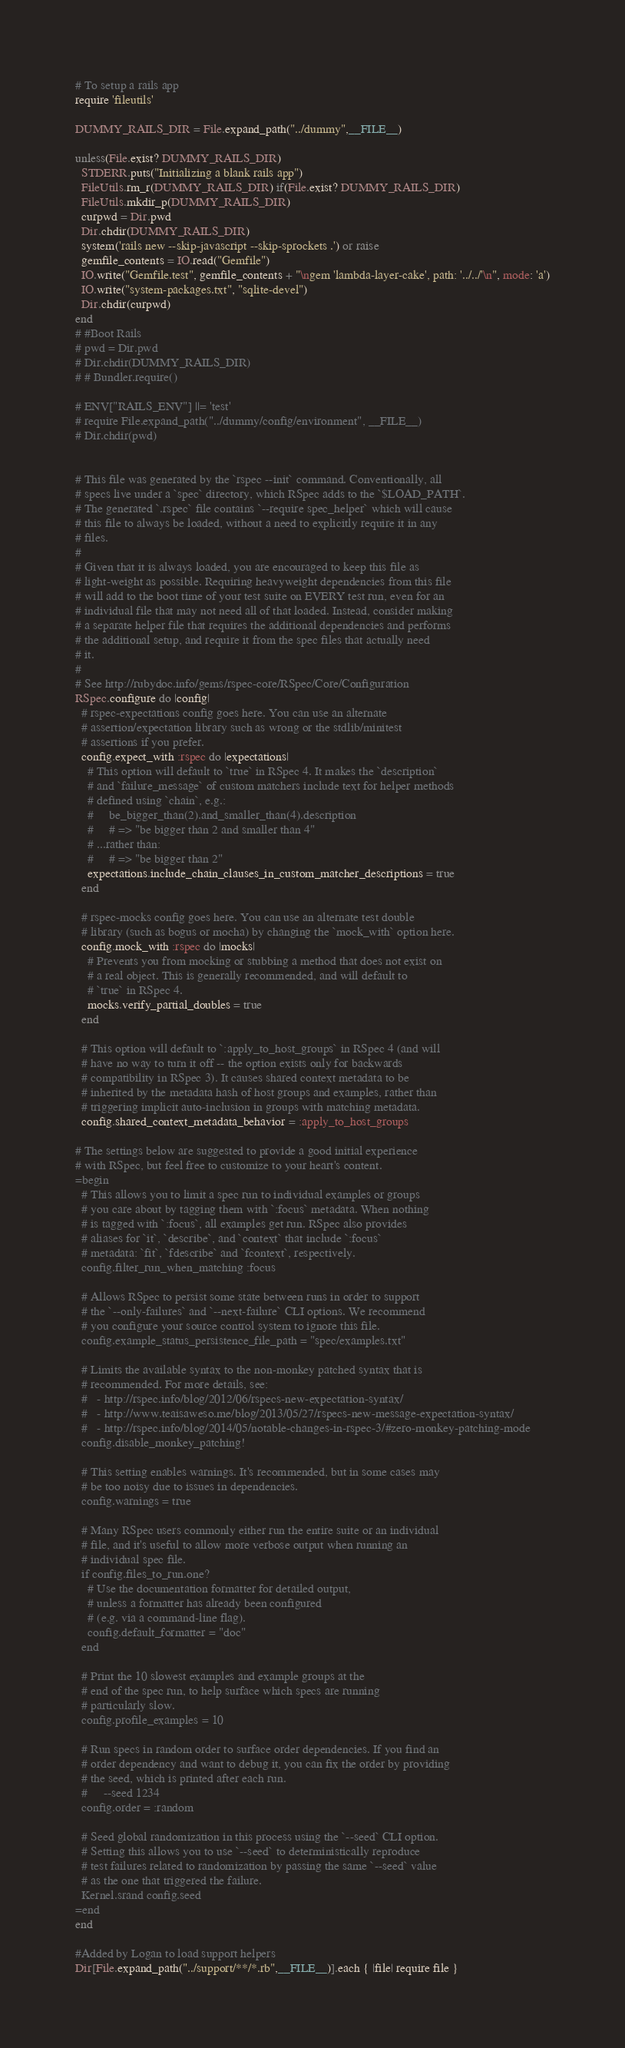<code> <loc_0><loc_0><loc_500><loc_500><_Ruby_># To setup a rails app
require 'fileutils'

DUMMY_RAILS_DIR = File.expand_path("../dummy",__FILE__)

unless(File.exist? DUMMY_RAILS_DIR)
  STDERR.puts("Initializing a blank rails app")
  FileUtils.rm_r(DUMMY_RAILS_DIR) if(File.exist? DUMMY_RAILS_DIR)
  FileUtils.mkdir_p(DUMMY_RAILS_DIR)
  curpwd = Dir.pwd
  Dir.chdir(DUMMY_RAILS_DIR)
  system('rails new --skip-javascript --skip-sprockets .') or raise
  gemfile_contents = IO.read("Gemfile")
  IO.write("Gemfile.test", gemfile_contents + "\ngem 'lambda-layer-cake', path: '../../'\n", mode: 'a')
  IO.write("system-packages.txt", "sqlite-devel")
  Dir.chdir(curpwd)  
end
# #Boot Rails
# pwd = Dir.pwd
# Dir.chdir(DUMMY_RAILS_DIR)
# # Bundler.require()

# ENV["RAILS_ENV"] ||= 'test'
# require File.expand_path("../dummy/config/environment", __FILE__)
# Dir.chdir(pwd)


# This file was generated by the `rspec --init` command. Conventionally, all
# specs live under a `spec` directory, which RSpec adds to the `$LOAD_PATH`.
# The generated `.rspec` file contains `--require spec_helper` which will cause
# this file to always be loaded, without a need to explicitly require it in any
# files.
#
# Given that it is always loaded, you are encouraged to keep this file as
# light-weight as possible. Requiring heavyweight dependencies from this file
# will add to the boot time of your test suite on EVERY test run, even for an
# individual file that may not need all of that loaded. Instead, consider making
# a separate helper file that requires the additional dependencies and performs
# the additional setup, and require it from the spec files that actually need
# it.
#
# See http://rubydoc.info/gems/rspec-core/RSpec/Core/Configuration
RSpec.configure do |config|
  # rspec-expectations config goes here. You can use an alternate
  # assertion/expectation library such as wrong or the stdlib/minitest
  # assertions if you prefer.
  config.expect_with :rspec do |expectations|
    # This option will default to `true` in RSpec 4. It makes the `description`
    # and `failure_message` of custom matchers include text for helper methods
    # defined using `chain`, e.g.:
    #     be_bigger_than(2).and_smaller_than(4).description
    #     # => "be bigger than 2 and smaller than 4"
    # ...rather than:
    #     # => "be bigger than 2"
    expectations.include_chain_clauses_in_custom_matcher_descriptions = true
  end

  # rspec-mocks config goes here. You can use an alternate test double
  # library (such as bogus or mocha) by changing the `mock_with` option here.
  config.mock_with :rspec do |mocks|
    # Prevents you from mocking or stubbing a method that does not exist on
    # a real object. This is generally recommended, and will default to
    # `true` in RSpec 4.
    mocks.verify_partial_doubles = true
  end

  # This option will default to `:apply_to_host_groups` in RSpec 4 (and will
  # have no way to turn it off -- the option exists only for backwards
  # compatibility in RSpec 3). It causes shared context metadata to be
  # inherited by the metadata hash of host groups and examples, rather than
  # triggering implicit auto-inclusion in groups with matching metadata.
  config.shared_context_metadata_behavior = :apply_to_host_groups

# The settings below are suggested to provide a good initial experience
# with RSpec, but feel free to customize to your heart's content.
=begin
  # This allows you to limit a spec run to individual examples or groups
  # you care about by tagging them with `:focus` metadata. When nothing
  # is tagged with `:focus`, all examples get run. RSpec also provides
  # aliases for `it`, `describe`, and `context` that include `:focus`
  # metadata: `fit`, `fdescribe` and `fcontext`, respectively.
  config.filter_run_when_matching :focus

  # Allows RSpec to persist some state between runs in order to support
  # the `--only-failures` and `--next-failure` CLI options. We recommend
  # you configure your source control system to ignore this file.
  config.example_status_persistence_file_path = "spec/examples.txt"

  # Limits the available syntax to the non-monkey patched syntax that is
  # recommended. For more details, see:
  #   - http://rspec.info/blog/2012/06/rspecs-new-expectation-syntax/
  #   - http://www.teaisaweso.me/blog/2013/05/27/rspecs-new-message-expectation-syntax/
  #   - http://rspec.info/blog/2014/05/notable-changes-in-rspec-3/#zero-monkey-patching-mode
  config.disable_monkey_patching!

  # This setting enables warnings. It's recommended, but in some cases may
  # be too noisy due to issues in dependencies.
  config.warnings = true

  # Many RSpec users commonly either run the entire suite or an individual
  # file, and it's useful to allow more verbose output when running an
  # individual spec file.
  if config.files_to_run.one?
    # Use the documentation formatter for detailed output,
    # unless a formatter has already been configured
    # (e.g. via a command-line flag).
    config.default_formatter = "doc"
  end

  # Print the 10 slowest examples and example groups at the
  # end of the spec run, to help surface which specs are running
  # particularly slow.
  config.profile_examples = 10

  # Run specs in random order to surface order dependencies. If you find an
  # order dependency and want to debug it, you can fix the order by providing
  # the seed, which is printed after each run.
  #     --seed 1234
  config.order = :random

  # Seed global randomization in this process using the `--seed` CLI option.
  # Setting this allows you to use `--seed` to deterministically reproduce
  # test failures related to randomization by passing the same `--seed` value
  # as the one that triggered the failure.
  Kernel.srand config.seed
=end
end

#Added by Logan to load support helpers
Dir[File.expand_path("../support/**/*.rb",__FILE__)].each { |file| require file }</code> 